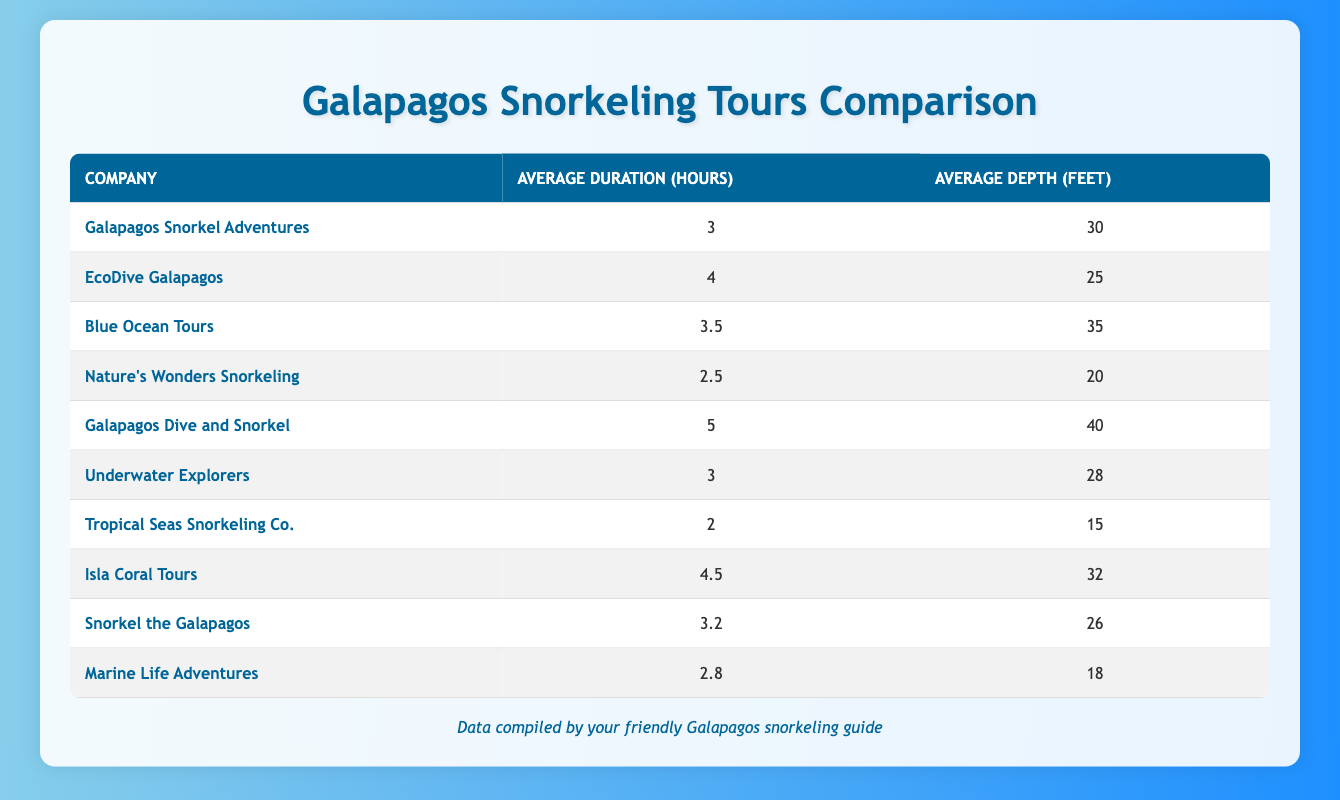What is the average duration of snorkeling tours offered by Galapagos Dive and Snorkel? The table lists Galapagos Dive and Snorkel with an average duration of 5 hours for their snorkeling tours.
Answer: 5 hours Which company offers the shortest average snorkeling tour duration? Looking through the table, Tropical Seas Snorkeling Co. has the shortest average tour duration at 2 hours.
Answer: Tropical Seas Snorkeling Co What is the average depth of the tours provided by Blue Ocean Tours? According to the table, Blue Ocean Tours has an average depth of 35 feet for their snorkeling tours.
Answer: 35 feet How many companies have an average duration of 4 hours or more? By checking the average durations, there are 4 companies (EcoDive Galapagos, Galapagos Dive and Snorkel, Isla Coral Tours, and EcoDive Galapagos) that meet this duration.
Answer: 4 companies Which snorkeling tour company has the deepest average exploration depth? The table indicates that Galapagos Dive and Snorkel has the deepest average exploration depth at 40 feet.
Answer: Galapagos Dive and Snorkel What is the average duration of snorkeling tours across all companies? To find the average, sum the durations (3 + 4 + 3.5 + 2.5 + 5 + 3 + 2 + 4.5 + 3.2 + 2.8 = 34) and divide by the number of companies (10), leading to an average duration of 3.4 hours.
Answer: 3.4 hours Is it true that EcoDive Galapagos offers a deeper tour on average than Snorkel the Galapagos? Yes, EcoDive Galapagos has an average depth of 25 feet, while Snorkel the Galapagos has an average depth of 26 feet, making the statement false.
Answer: False Which company provides the longest average snorkeling tour duration among the top three longest? The top three longest durations are Galapagos Dive and Snorkel (5 hours), Isla Coral Tours (4.5 hours), and EcoDive Galapagos (4 hours). Galapagos Dive and Snorkel has the longest duration.
Answer: Galapagos Dive and Snorkel What is the difference in average depth between Marine Life Adventures and Tropical Seas Snorkeling Co.? Marine Life Adventures has an average depth of 18 feet, and Tropical Seas Snorkeling Co. has an average depth of 15 feet. The difference is 18 - 15 = 3 feet.
Answer: 3 feet Are there more companies with average tour durations below 3 hours than above? Yes, there are 4 companies (Nature's Wonders Snorkeling, Tropical Seas Snorkeling Co., Marine Life Adventures) with averages below 3 hours and only 3 above this mark.
Answer: Yes 